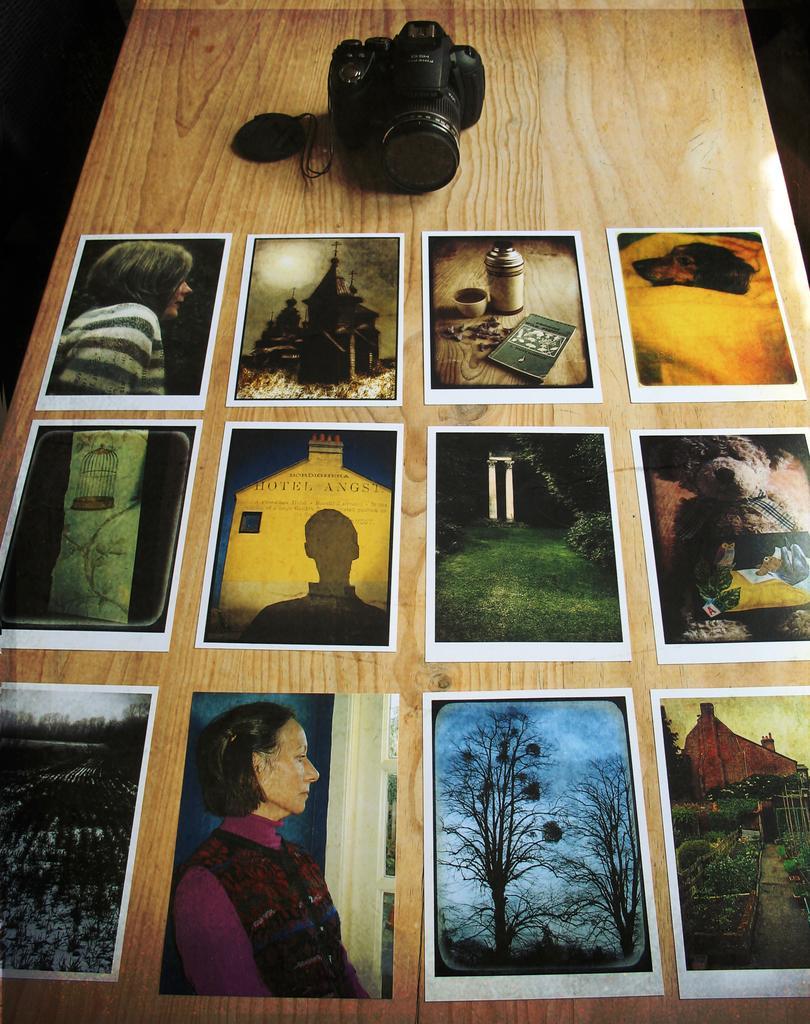Can you describe this image briefly? In the image there is a camera with many photographs in front of it on a wooden table. 